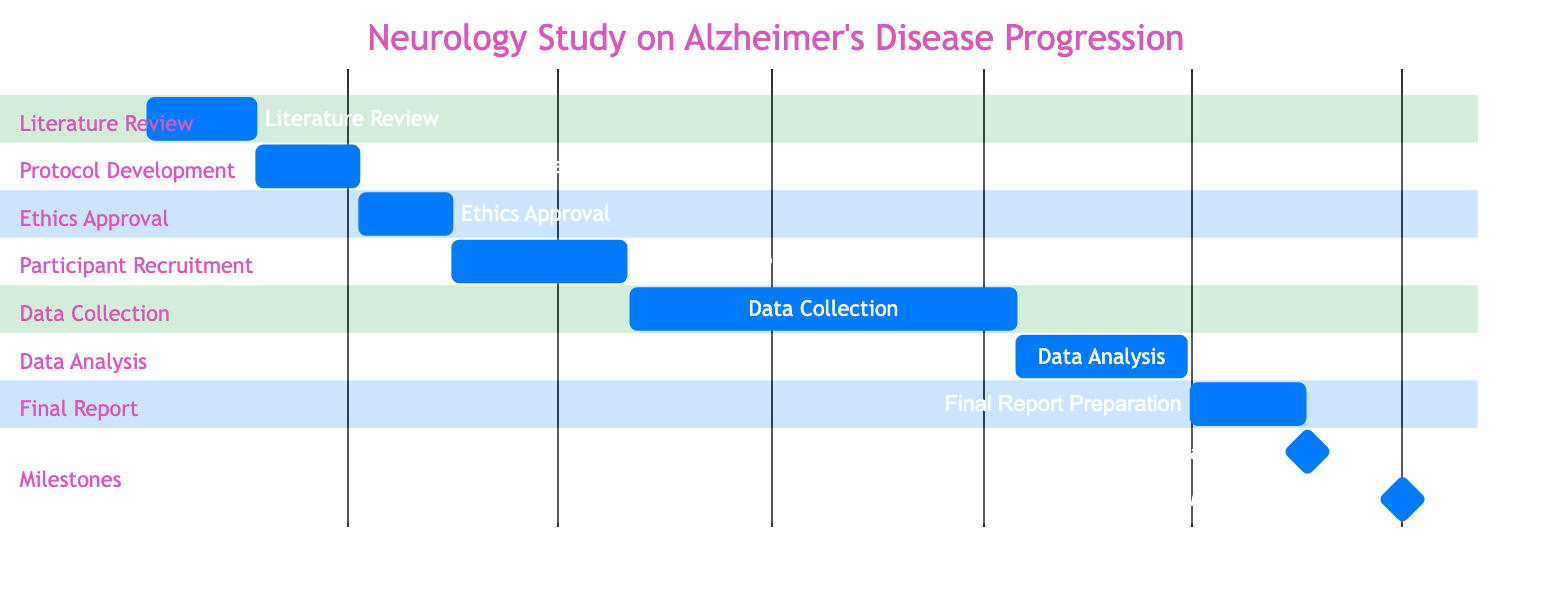What is the duration of the Data Analysis phase? The Data Analysis phase starts on January 16, 2025, and ends on March 30, 2025. The duration is calculated by finding the total number of days between these dates, which is 73 days.
Answer: 73 days What is the first task listed in the project? The tasks are presented in chronological order, and the first task listed is the Literature Review, which starts on January 5, 2024.
Answer: Literature Review What is the deadline for submitting the manuscript? The diagram indicates that the Submit Manuscript task is scheduled for May 21, 2025, as it is marked as a milestone task.
Answer: May 21, 2025 How many tasks are scheduled between Literature Review and Data Collection? The tasks between these phases are Protocol Development, Ethics Approval, and Participant Recruitment. Counting these, there are three tasks in total.
Answer: 3 tasks Which milestone comes after Final Report Preparation? The diagram lists the Final Report Preparation ending on May 20, 2025; the next milestone task is Submit Manuscript, which starts on May 21, 2025. This shows the immediate progression from report preparation to manuscript submission.
Answer: Submit Manuscript What is the total length of the project from start to finish? The project begins on January 5, 2024, with the Literature Review and ends on July 15, 2025, with the Conference Presentation. The total duration is calculated by identifying the start and end date spans, which is approximately 1 year and 6 months.
Answer: Approximately 1 year and 6 months Which task has the longest duration? By examining the timeline, the task with the longest duration is Data Collection, lasting from August 1, 2024, to January 15, 2025, which totals 167 days.
Answer: Data Collection What is the starting date for Participant Recruitment? The diagram clearly shows that the Participant Recruitment phase commences on May 16, 2024. This is derived directly from the task’s start date in the Gantt chart.
Answer: May 16, 2024 What is the last milestone of the project? The last milestone depicted in the Gantt chart is the Conference Presentation, which occurs from July 1, 2025, to July 15, 2025. This is the final marker highlighted in the timeline.
Answer: Conference Presentation 